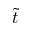<formula> <loc_0><loc_0><loc_500><loc_500>\tilde { t }</formula> 